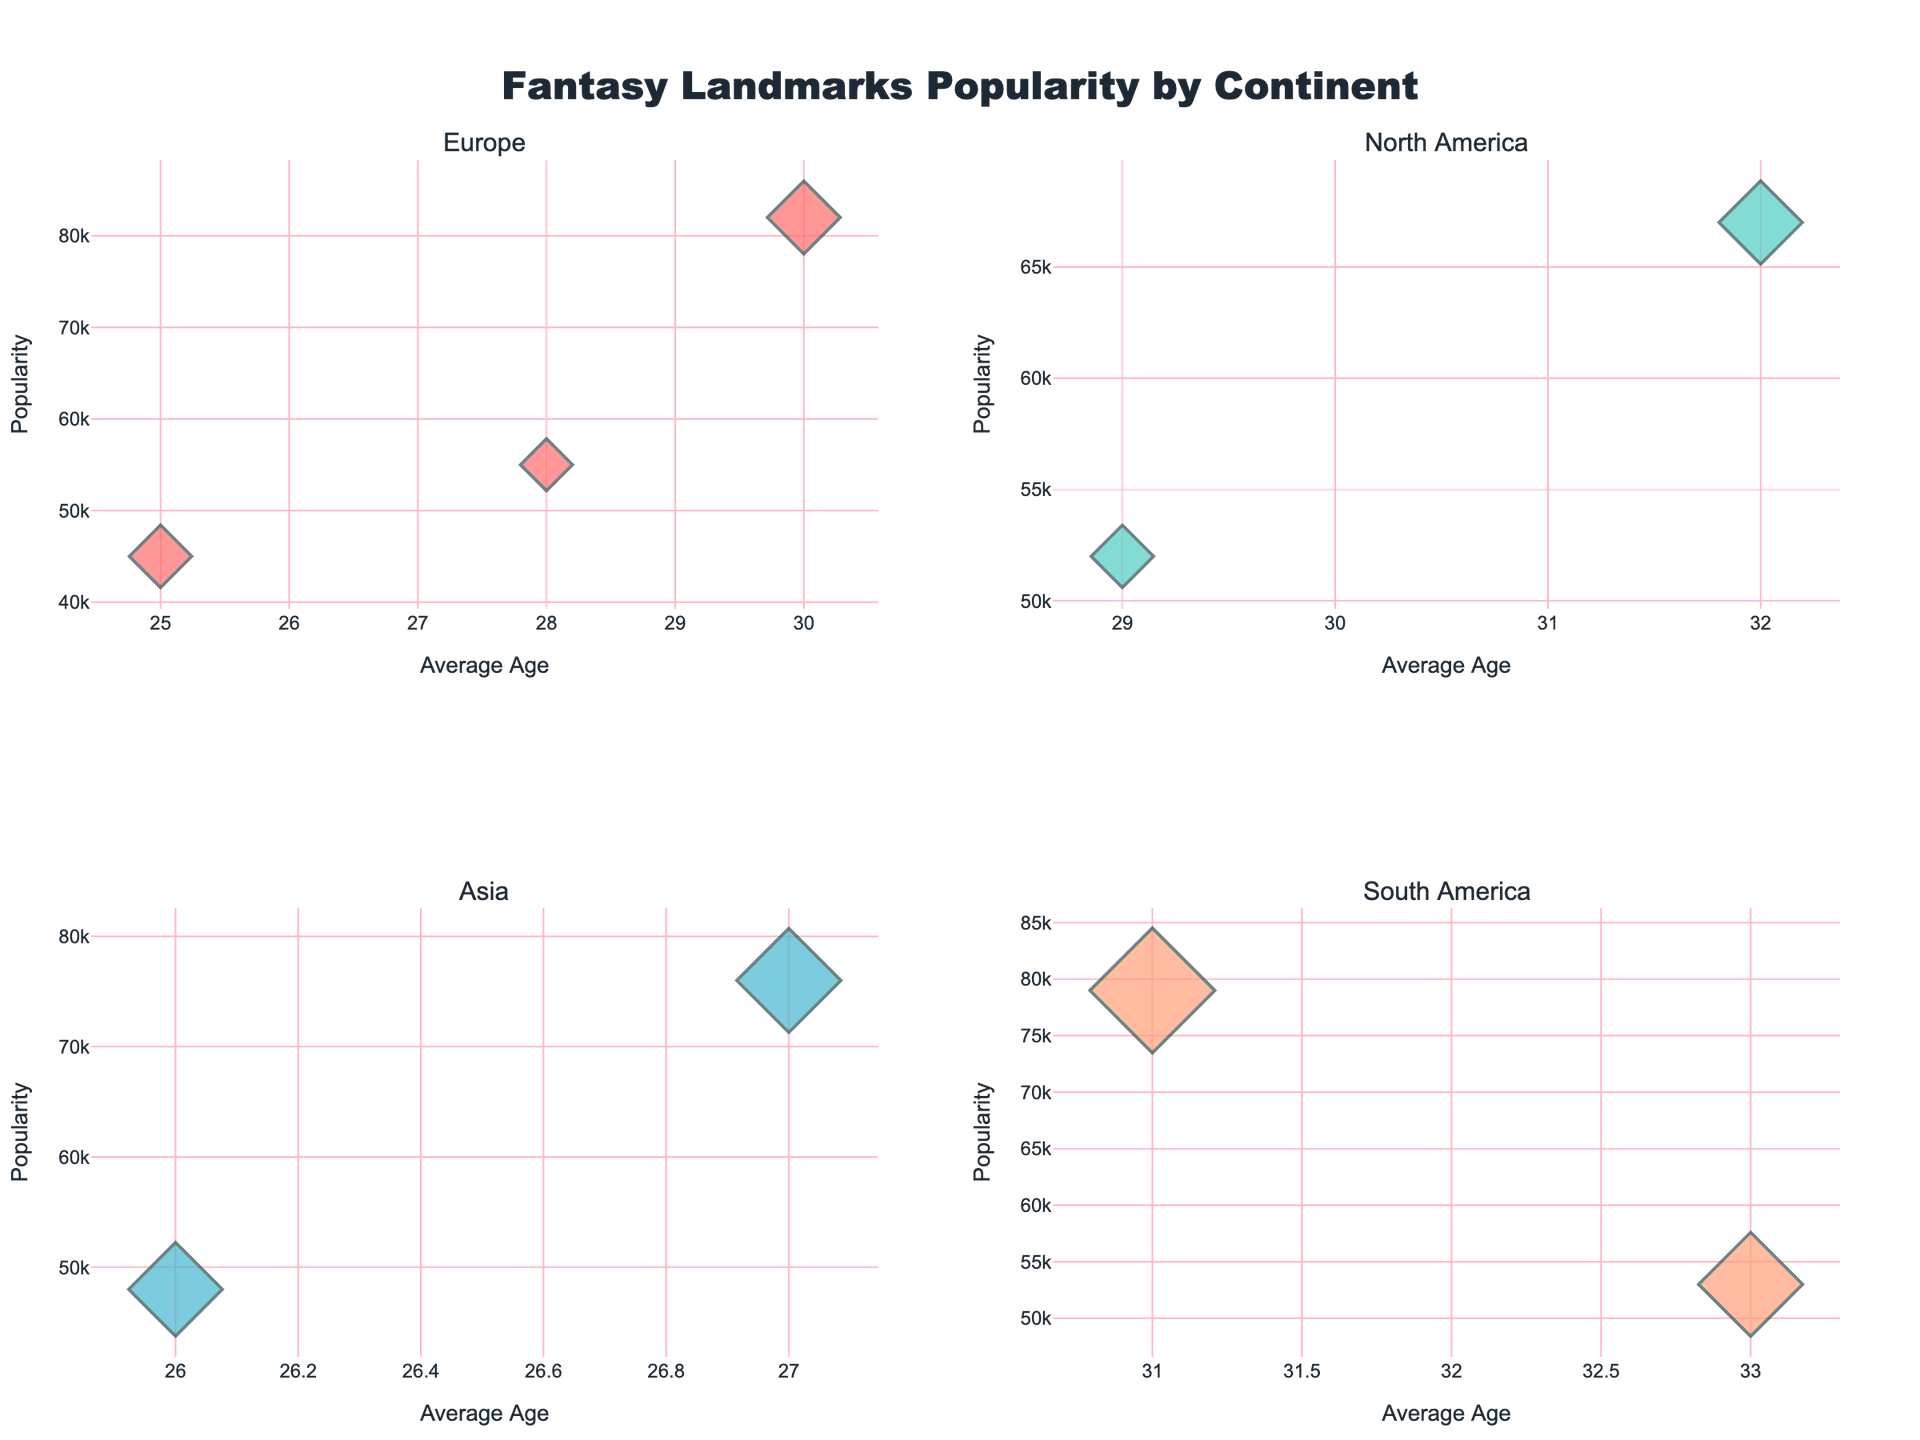What's the most popular landmark in Europe? By looking at the subplot for Europe, the highest bubble on the y-axis (indicating popularity) represents Alnwick Castle (Hogwarts) with a value of 82,000.
Answer: Alnwick Castle (Hogwarts) In which continent do people, on average, spend the longest time at landmarks? Examine the bubbles across all subplots; South America has the largest average bubble sizes indicating longer average stays. Patagonia (Hyperborea) and Machu Picchu (El Dorado) both show high average stay durations of 5 and 6 hours respectively.
Answer: South America Which landmark has the youngest visitors on average? Compare the positions on the x-axis representing average age across all subplots. Reine (Frozen) in Europe has the lowest x-axis value with an average age of 25 years.
Answer: Reine (Frozen) How does the popularity of Jiuzhaigou Valley (Pandora) compare with that of Mount Desert Island (Narnia)? Jiuzhaigou Valley (Pandora) in Asia has a bubble positioned higher on the y-axis than Mount Desert Island (Narnia) in North America, indicating Jiuzhaigou Valley is more popular with 76,000 visitors compared to 52,000.
Answer: Jiuzhaigou Valley (Pandora) is more popular What is the average popularity of landmarks in North America? Sum up the popularity values for Cathedral Peak (67,000) and Mount Desert Island (52,000) and divide by the total number of landmarks (2): (67,000 + 52,000) / 2.
Answer: 59,500 Which continent has the oldest average visitor age? Compare the average age values across all subplots; North America with Cathedral Peak and Mount Desert Island showing average visitor ages of 32 and 29 years respectively reflects the oldest average age.
Answer: North America What is the difference in average stay duration between Halong Bay (Avatar) and Cliffs of Moher (Harry Potter)? The average stay at Halong Bay is 4.5 hours while at Cliffs of Moher it is 2.5 hours, so the difference is 4.5 - 2.5.
Answer: 2 hours Which landmark has a larger bubble size in the Asia subplot? Comparing the bubble sizes in the Asia subplot, Jiuzhaigou Valley (Pandora) has a larger bubble size than Halong Bay (Avatar), indicating a longer average stay duration (5 hours vs 4.5 hours).
Answer: Jiuzhaigou Valley (Pandora) What's the popularity of the least visited landmark and where is it located? The smallest bubble in terms of height on the y-axis across all subplots represents Reine (Frozen) in Europe with a popularity of 45,000.
Answer: Reine (Frozen), Europe Do older or younger travelers prefer Patagonia (Hyperborea)? By observing the x-axis position of Patagonia (Hyperborea) in the South America plot, the average visitor age is 33, indicating it is preferred by older travelers.
Answer: Older travelers 